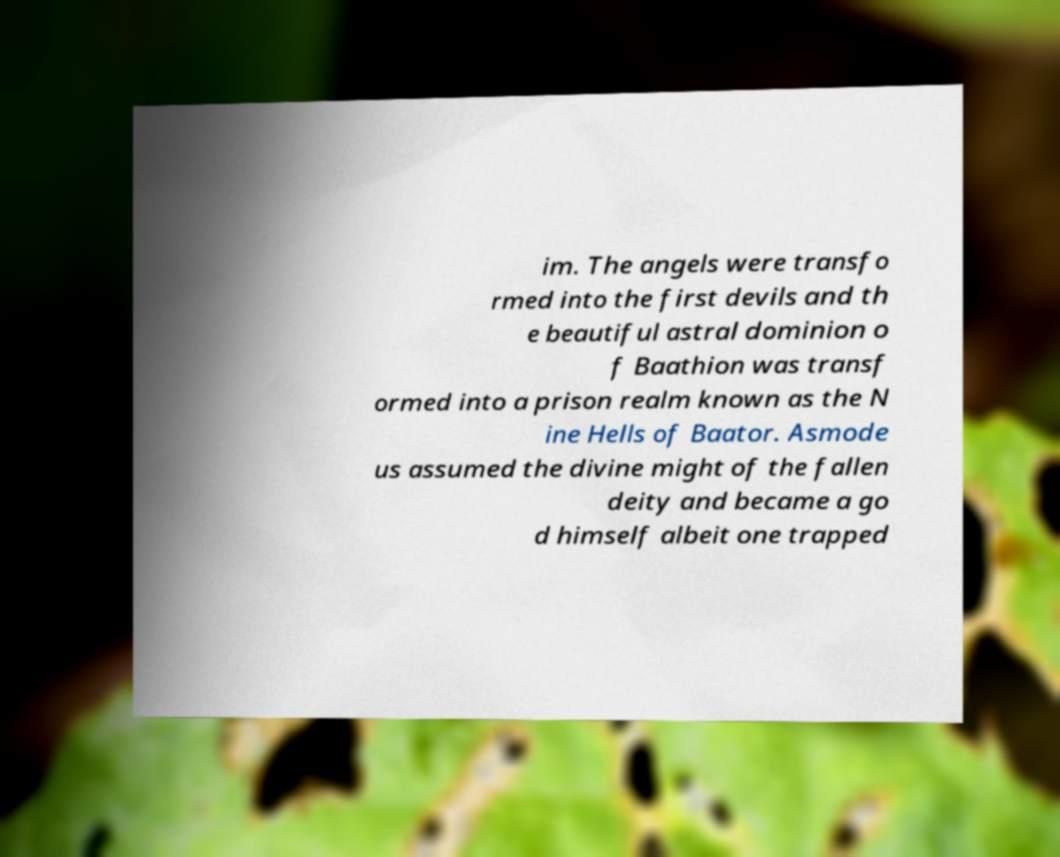I need the written content from this picture converted into text. Can you do that? im. The angels were transfo rmed into the first devils and th e beautiful astral dominion o f Baathion was transf ormed into a prison realm known as the N ine Hells of Baator. Asmode us assumed the divine might of the fallen deity and became a go d himself albeit one trapped 